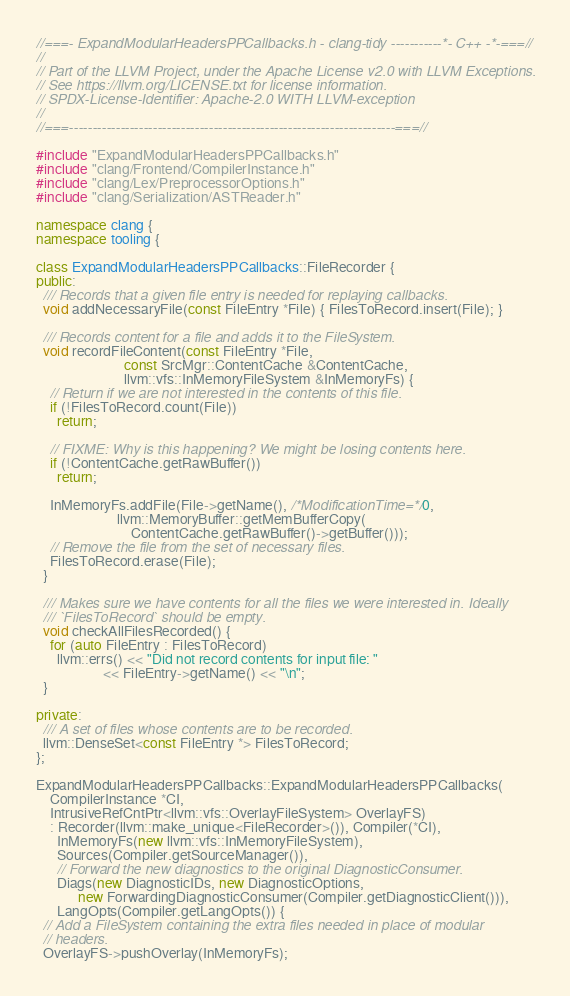Convert code to text. <code><loc_0><loc_0><loc_500><loc_500><_C++_>//===- ExpandModularHeadersPPCallbacks.h - clang-tidy -----------*- C++ -*-===//
//
// Part of the LLVM Project, under the Apache License v2.0 with LLVM Exceptions.
// See https://llvm.org/LICENSE.txt for license information.
// SPDX-License-Identifier: Apache-2.0 WITH LLVM-exception
//
//===----------------------------------------------------------------------===//

#include "ExpandModularHeadersPPCallbacks.h"
#include "clang/Frontend/CompilerInstance.h"
#include "clang/Lex/PreprocessorOptions.h"
#include "clang/Serialization/ASTReader.h"

namespace clang {
namespace tooling {

class ExpandModularHeadersPPCallbacks::FileRecorder {
public:
  /// Records that a given file entry is needed for replaying callbacks.
  void addNecessaryFile(const FileEntry *File) { FilesToRecord.insert(File); }

  /// Records content for a file and adds it to the FileSystem.
  void recordFileContent(const FileEntry *File,
                         const SrcMgr::ContentCache &ContentCache,
                         llvm::vfs::InMemoryFileSystem &InMemoryFs) {
    // Return if we are not interested in the contents of this file.
    if (!FilesToRecord.count(File))
      return;

    // FIXME: Why is this happening? We might be losing contents here.
    if (!ContentCache.getRawBuffer())
      return;

    InMemoryFs.addFile(File->getName(), /*ModificationTime=*/0,
                       llvm::MemoryBuffer::getMemBufferCopy(
                           ContentCache.getRawBuffer()->getBuffer()));
    // Remove the file from the set of necessary files.
    FilesToRecord.erase(File);
  }

  /// Makes sure we have contents for all the files we were interested in. Ideally
  /// `FilesToRecord` should be empty.
  void checkAllFilesRecorded() {
    for (auto FileEntry : FilesToRecord)
      llvm::errs() << "Did not record contents for input file: "
                   << FileEntry->getName() << "\n";
  }

private:
  /// A set of files whose contents are to be recorded.
  llvm::DenseSet<const FileEntry *> FilesToRecord;
};

ExpandModularHeadersPPCallbacks::ExpandModularHeadersPPCallbacks(
    CompilerInstance *CI,
    IntrusiveRefCntPtr<llvm::vfs::OverlayFileSystem> OverlayFS)
    : Recorder(llvm::make_unique<FileRecorder>()), Compiler(*CI),
      InMemoryFs(new llvm::vfs::InMemoryFileSystem),
      Sources(Compiler.getSourceManager()),
      // Forward the new diagnostics to the original DiagnosticConsumer.
      Diags(new DiagnosticIDs, new DiagnosticOptions,
            new ForwardingDiagnosticConsumer(Compiler.getDiagnosticClient())),
      LangOpts(Compiler.getLangOpts()) {
  // Add a FileSystem containing the extra files needed in place of modular
  // headers.
  OverlayFS->pushOverlay(InMemoryFs);
</code> 